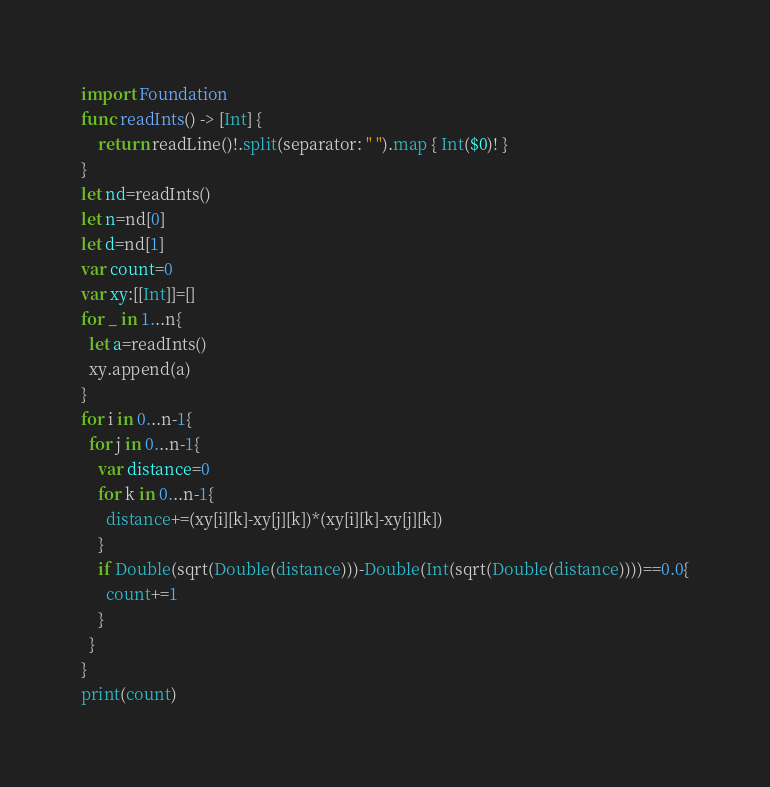Convert code to text. <code><loc_0><loc_0><loc_500><loc_500><_Swift_>import Foundation
func readInts() -> [Int] {
    return readLine()!.split(separator: " ").map { Int($0)! }
}
let nd=readInts()
let n=nd[0]
let d=nd[1]
var count=0
var xy:[[Int]]=[]
for _ in 1...n{
  let a=readInts()
  xy.append(a)
}
for i in 0...n-1{
  for j in 0...n-1{
    var distance=0
    for k in 0...n-1{
      distance+=(xy[i][k]-xy[j][k])*(xy[i][k]-xy[j][k])
    }
    if Double(sqrt(Double(distance)))-Double(Int(sqrt(Double(distance))))==0.0{
      count+=1
    }
  }
}
print(count)

</code> 